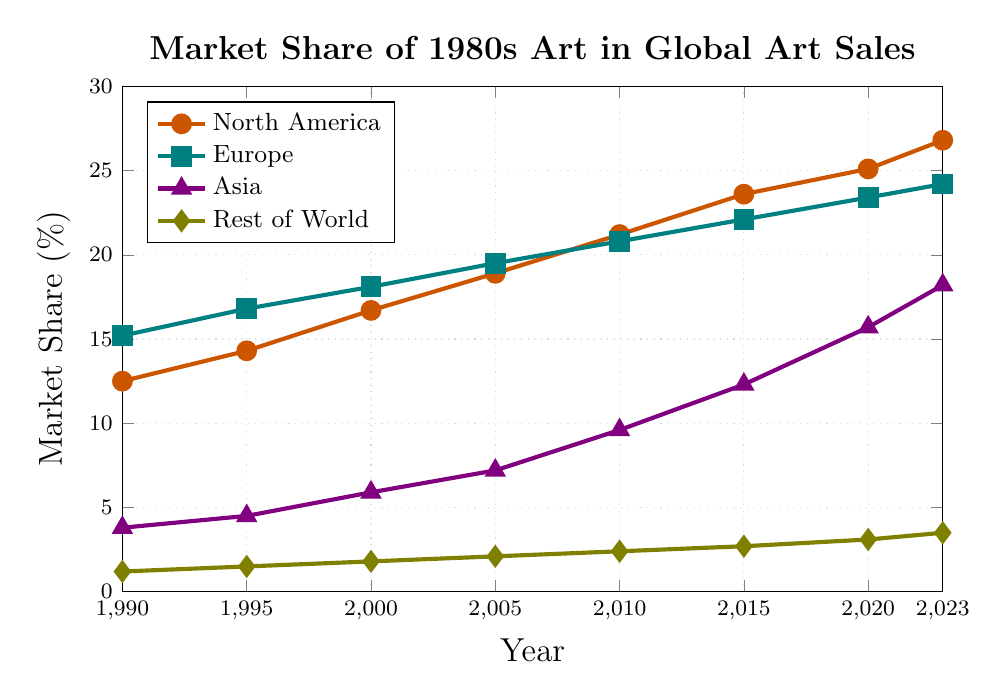What is the market share of 1980s art in North America in 2023? To find the market share of 1980s art in North America in 2023, look at the point on the line for North America corresponding to the year 2023.
Answer: 26.8% What was the earliest year in which Asia's market share exceeded 10%? First, locate the points on Asia's line and identify the year where it first surpasses 10%. Notice the market shares for Asia in each year: 3.8%, 4.5%, 5.9%, 7.2%, 9.6%, 12.3%, 15.7%, and 18.2%. The first year it exceeds 10% is 2015.
Answer: 2015 Which region had the highest market share increase from 1990 to 2023? Calculate the difference between the market shares in 1990 and 2023 for each region. North America: 26.8 - 12.5 = 14.3, Europe: 24.2 - 15.2 = 9.0, Asia: 18.2 - 3.8 = 14.4, Rest of World: 3.5 - 1.2 = 2.3. Asia had the highest increase.
Answer: Asia What was the combined market share of Europe and Asia in 2010? Add the market shares of Europe and Asia in 2010. Europe had 20.8% and Asia had 9.6%. So, 20.8 + 9.6 = 30.4%.
Answer: 30.4% Between 2015 and 2023, which region experienced the smallest increase in market share? Subtract the market share in 2015 from the market share in 2023 for each region to find the increase over these years. North America: 26.8 - 23.6 = 3.2, Europe: 24.2 - 22.1 = 2.1, Asia: 18.2 - 12.3 = 5.9, Rest of World: 3.5 - 2.7 = 0.8. The Rest of World experienced the smallest increase.
Answer: Rest of World In what year did North America surpass 20% market share? Identify the first year in which North America's market share exceeds 20%. This occurs in 2010, where the value is 21.2%.
Answer: 2010 How does the market share growth trend for Europe compare to North America from 1990 to 2023? Compare the slopes of the lines representing Europe and North America. North America's line has a steeper slope, indicating a faster growth rate (from 12.5% to 26.8%) compared to Europe's (from 15.2% to 24.2%).
Answer: North America experienced faster growth What is the average market share of 1980s art for Rest of the World between 1990 and 2023? The average is calculated by summing the market share values for Rest of the World across all years and dividing by the number of years: (1.2 + 1.5 + 1.8 + 2.1 + 2.4 + 2.7 + 3.1 + 3.5) / 8. Sum is 18.3, so 18.3 / 8 = 2.29%.
Answer: 2.29% By how much did Asia's market share increase from 1990 to 2020? Subtract the market share of Asia in 1990 from that in 2020. 15.7 - 3.8 = 11.9%.
Answer: 11.9% Which geographical region consistently increased its market share from 1990 to 2023? Observe the trends for each region’s line. All regions show an increasing trend throughout the years, though North America, Europe, and Asia have more pronounced increases.
Answer: North America, Europe, Asia, and Rest of World 